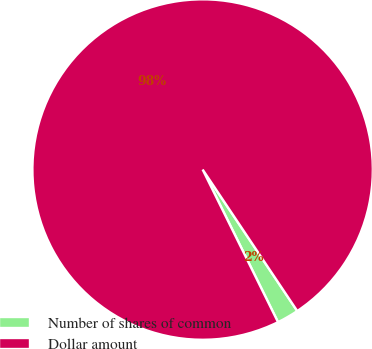Convert chart to OTSL. <chart><loc_0><loc_0><loc_500><loc_500><pie_chart><fcel>Number of shares of common<fcel>Dollar amount<nl><fcel>2.08%<fcel>97.92%<nl></chart> 